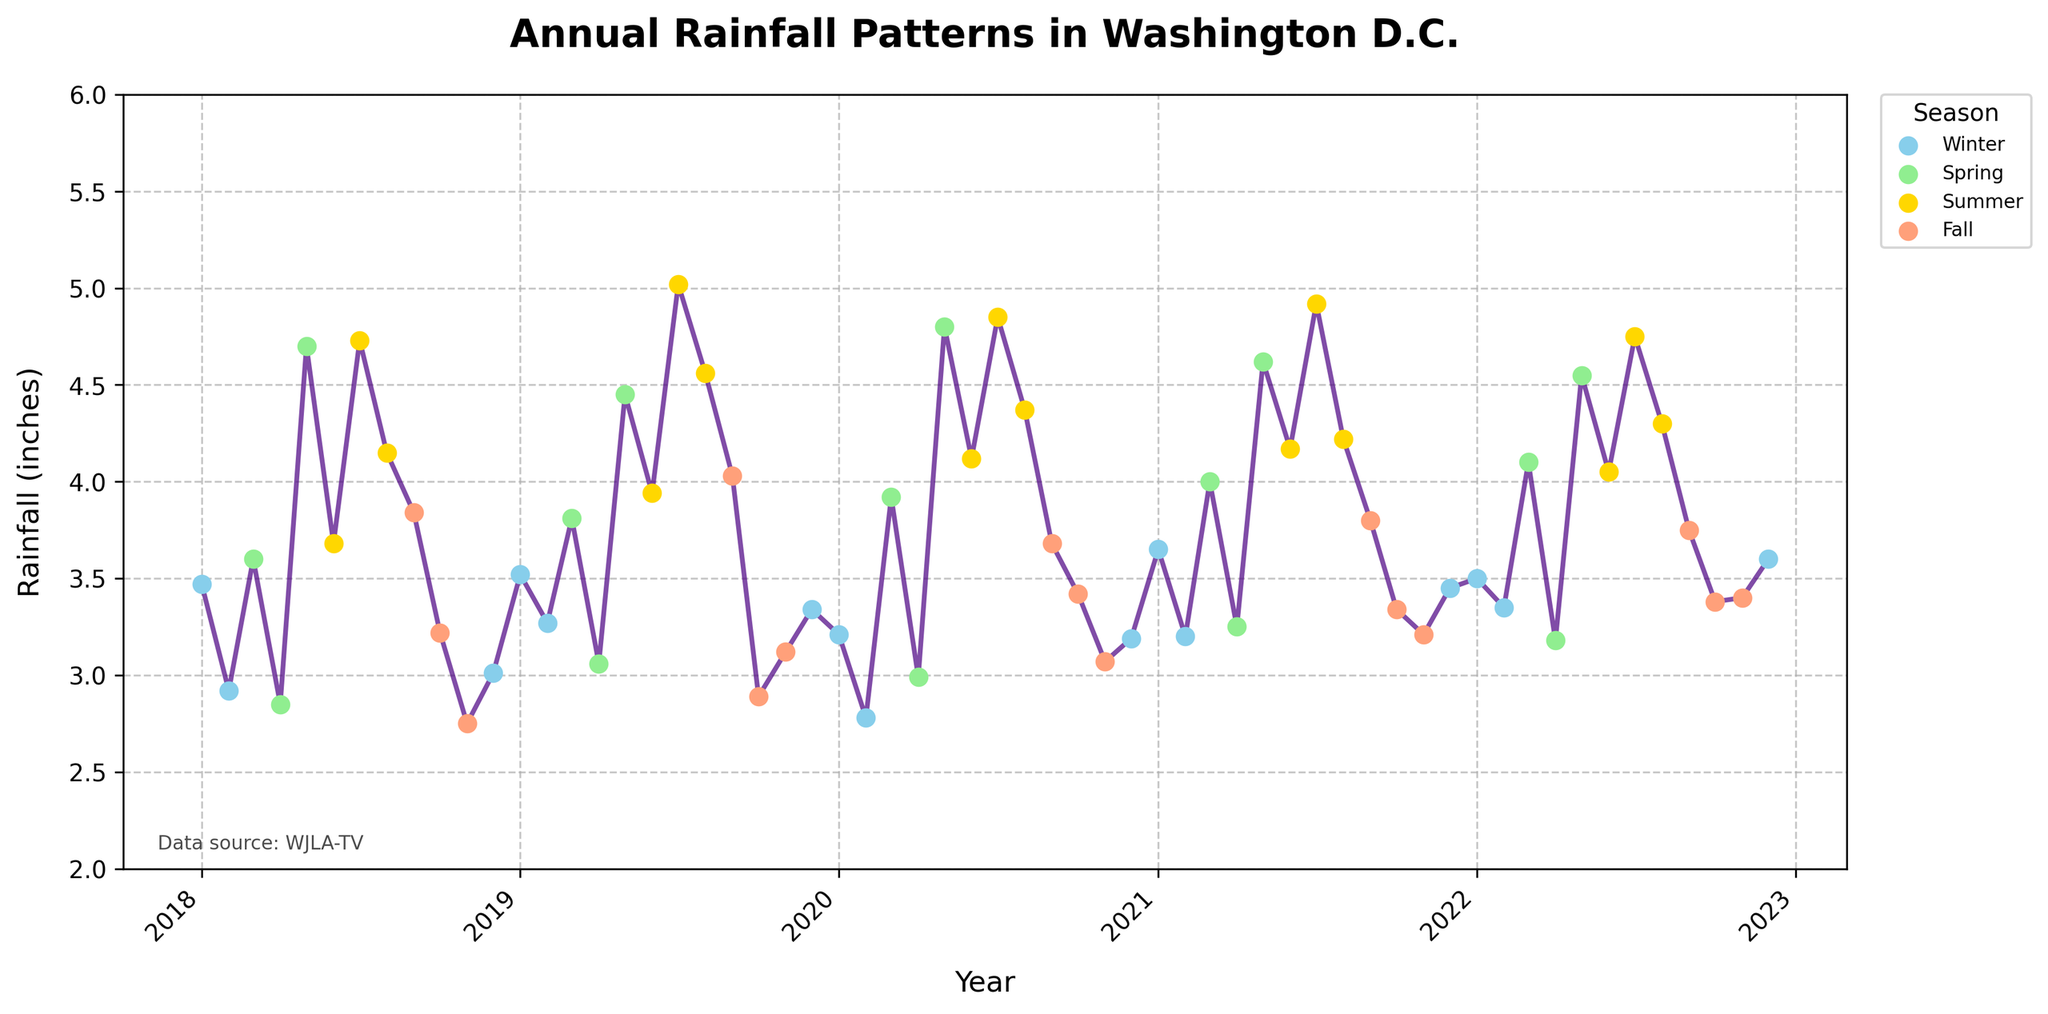How does the rainfall in July 2021 compare to July of other years? To compare, identify the rainfall amounts for July across the years from the plot. July 2018 has approximately 4.73 inches, July 2019 is around 5.02 inches, July 2020 is roughly 4.85 inches, July 2021 is about 4.92 inches, and July 2022 is approximately 4.75 inches. Comparing these, July 2021 has a slightly higher rainfall than July in most other years.
Answer: Slightly higher What is the general trend in rainfall for the month of May across the years? Examine the rainfall amounts for each May from the plot: May 2018 is approximately 4.70 inches, May 2019 is around 4.45 inches, May 2020 is about 4.80 inches, May 2021 is roughly 4.62 inches, and May 2022 is around 4.55 inches. The trend is relatively stable with some slight fluctuations.
Answer: Stable with slight fluctuations Which season has the most visually noticeable increase in rainfall amounts from year to year? Inspecting the scatter points colored by season, we see the Summer season (yellow markers) has several instances of increasing rainfall amounts over the years, particularly noticeable with higher peaks each year.
Answer: Summer During which years did Washington D.C. have their highest recorded rainfall in December according to the visual? Check December rainfall markers in the plot. The highest markers for December are: December 2022 (3.60 inches), and December 2018 (3.01 inches). The year 2022 had the highest rainfall in December.
Answer: 2022 How does the highest rainfall recorded in any fall month compare with the highest in any winter month? The highest recorded fall month rainfall, October 2020 (3.42 inches), November 2022 (3.40 inches). The highest winter month rainfall, January 2021 (3.65 inches), February 2019 (3.27 inches). January 2021's 3.65 inches exceed the highest fall month rainfall by 0.23 inches.
Answer: January 2021 is 0.23 inches higher Which months over the years consistently have less than 3 inches of rainfall? Check months with markers consistently below 3 inches: Feb 2018 (2.92), Apr 2018 (2.85), Nov 2018 (2.75), Feb 2020 (2.78). Feb and Apr often fall below 3 inches.
Answer: Feb and Apr 